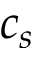Convert formula to latex. <formula><loc_0><loc_0><loc_500><loc_500>c _ { s }</formula> 